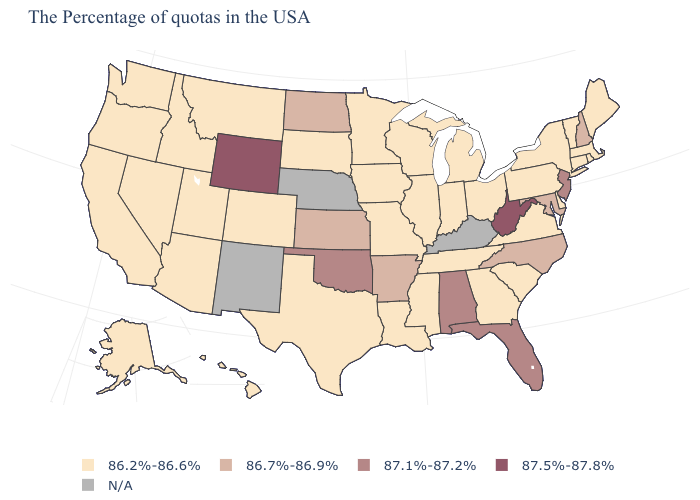How many symbols are there in the legend?
Give a very brief answer. 5. How many symbols are there in the legend?
Quick response, please. 5. What is the lowest value in states that border Rhode Island?
Quick response, please. 86.2%-86.6%. How many symbols are there in the legend?
Answer briefly. 5. What is the highest value in the USA?
Keep it brief. 87.5%-87.8%. What is the value of California?
Keep it brief. 86.2%-86.6%. How many symbols are there in the legend?
Be succinct. 5. What is the value of Mississippi?
Keep it brief. 86.2%-86.6%. Name the states that have a value in the range 87.5%-87.8%?
Write a very short answer. West Virginia, Wyoming. What is the lowest value in the Northeast?
Keep it brief. 86.2%-86.6%. What is the value of Nebraska?
Give a very brief answer. N/A. Which states hav the highest value in the Northeast?
Short answer required. New Jersey. What is the lowest value in the USA?
Quick response, please. 86.2%-86.6%. 